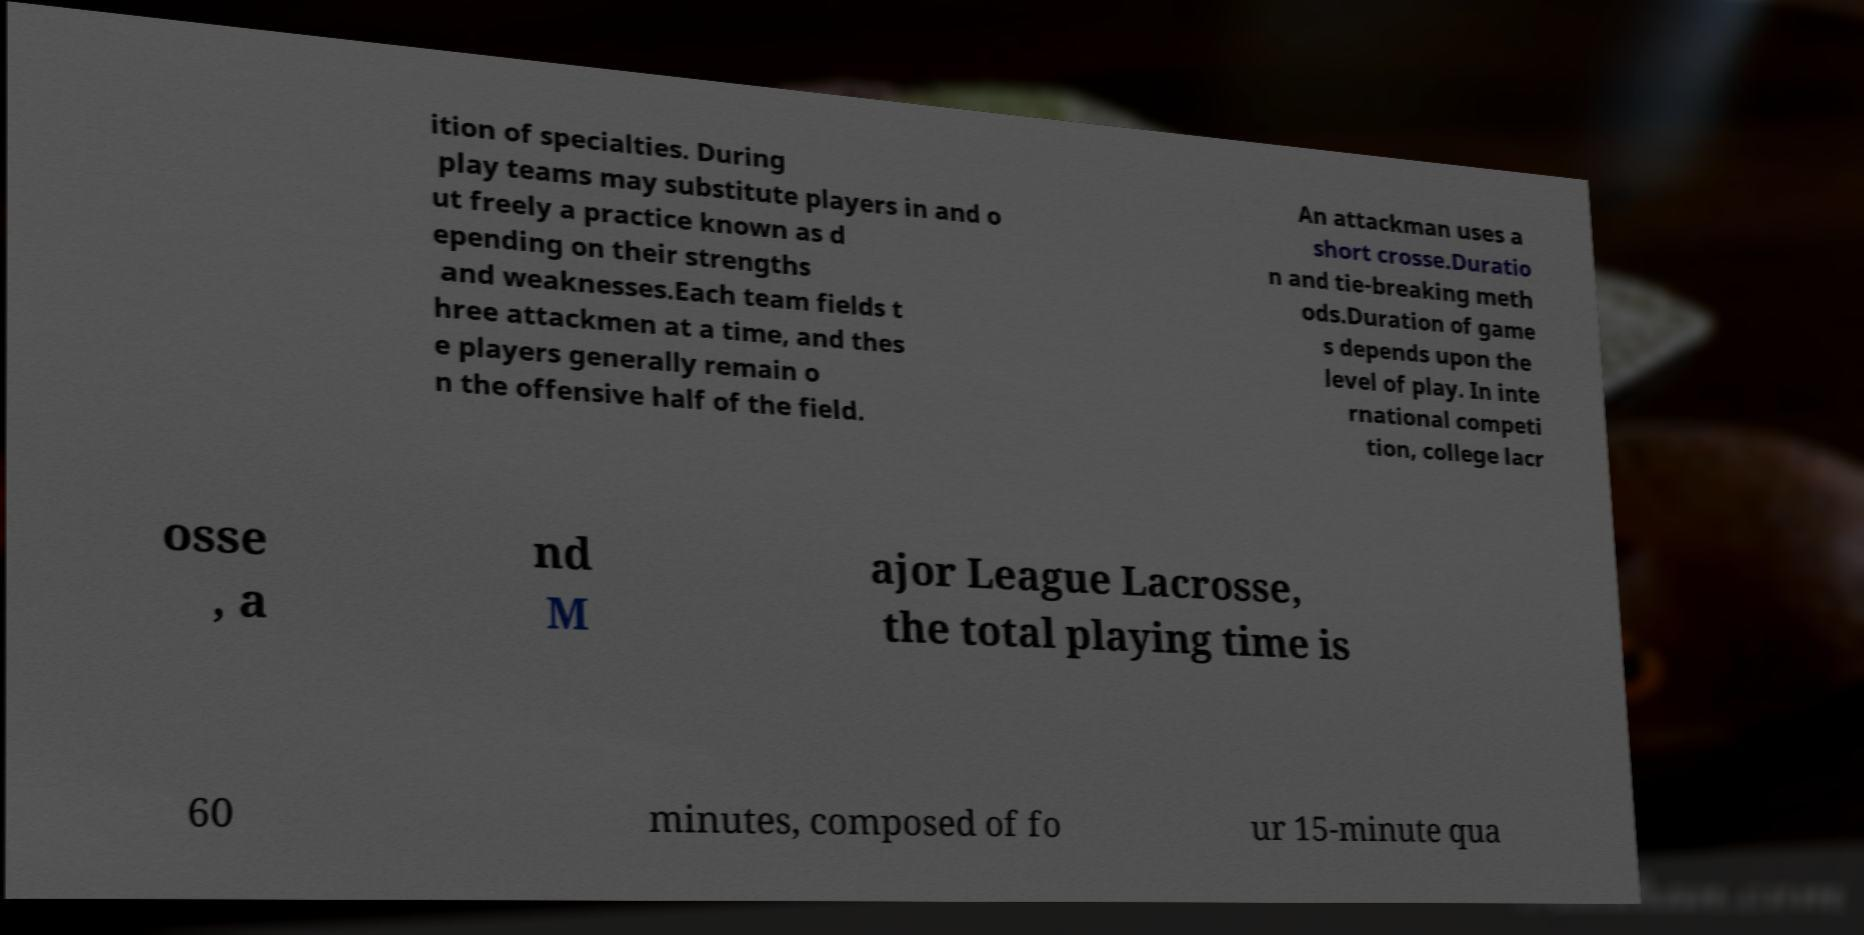Can you read and provide the text displayed in the image?This photo seems to have some interesting text. Can you extract and type it out for me? ition of specialties. During play teams may substitute players in and o ut freely a practice known as d epending on their strengths and weaknesses.Each team fields t hree attackmen at a time, and thes e players generally remain o n the offensive half of the field. An attackman uses a short crosse.Duratio n and tie-breaking meth ods.Duration of game s depends upon the level of play. In inte rnational competi tion, college lacr osse , a nd M ajor League Lacrosse, the total playing time is 60 minutes, composed of fo ur 15-minute qua 